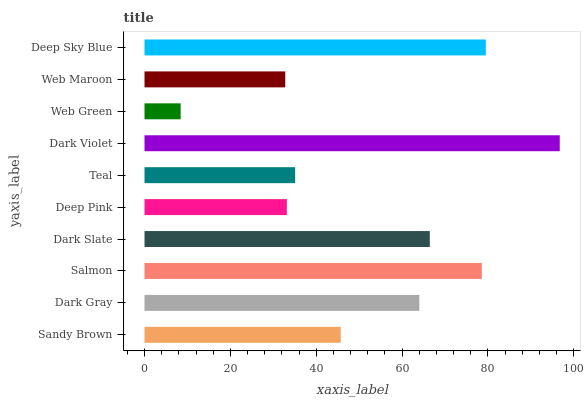Is Web Green the minimum?
Answer yes or no. Yes. Is Dark Violet the maximum?
Answer yes or no. Yes. Is Dark Gray the minimum?
Answer yes or no. No. Is Dark Gray the maximum?
Answer yes or no. No. Is Dark Gray greater than Sandy Brown?
Answer yes or no. Yes. Is Sandy Brown less than Dark Gray?
Answer yes or no. Yes. Is Sandy Brown greater than Dark Gray?
Answer yes or no. No. Is Dark Gray less than Sandy Brown?
Answer yes or no. No. Is Dark Gray the high median?
Answer yes or no. Yes. Is Sandy Brown the low median?
Answer yes or no. Yes. Is Dark Slate the high median?
Answer yes or no. No. Is Web Maroon the low median?
Answer yes or no. No. 